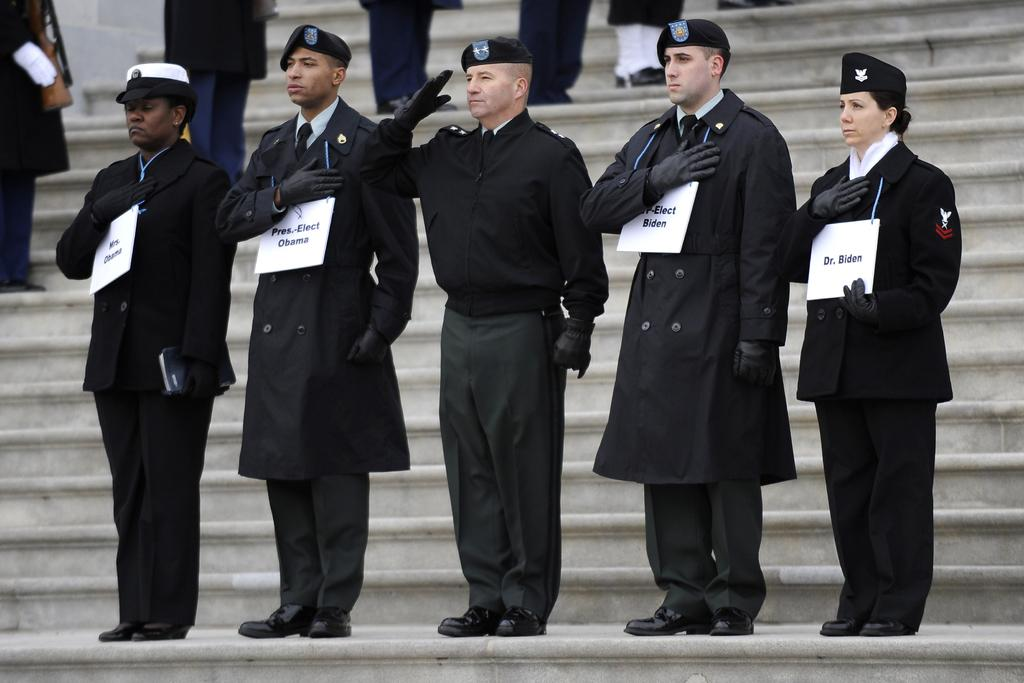Who or what is present in the image? There are people in the image. What are the people doing in the image? The people are standing on steps. What can be observed about the clothing of some people in the front? Some people in the front are wearing black clothes. What can be seen on the heads of some people in the front? Some people in the front are wearing hats. What else can be seen among the people in the image? There are other objects present among the people. How does the bomb affect the people in the image? There is no bomb present in the image; it only features people standing on steps, wearing black clothes and hats, and other objects among them. 